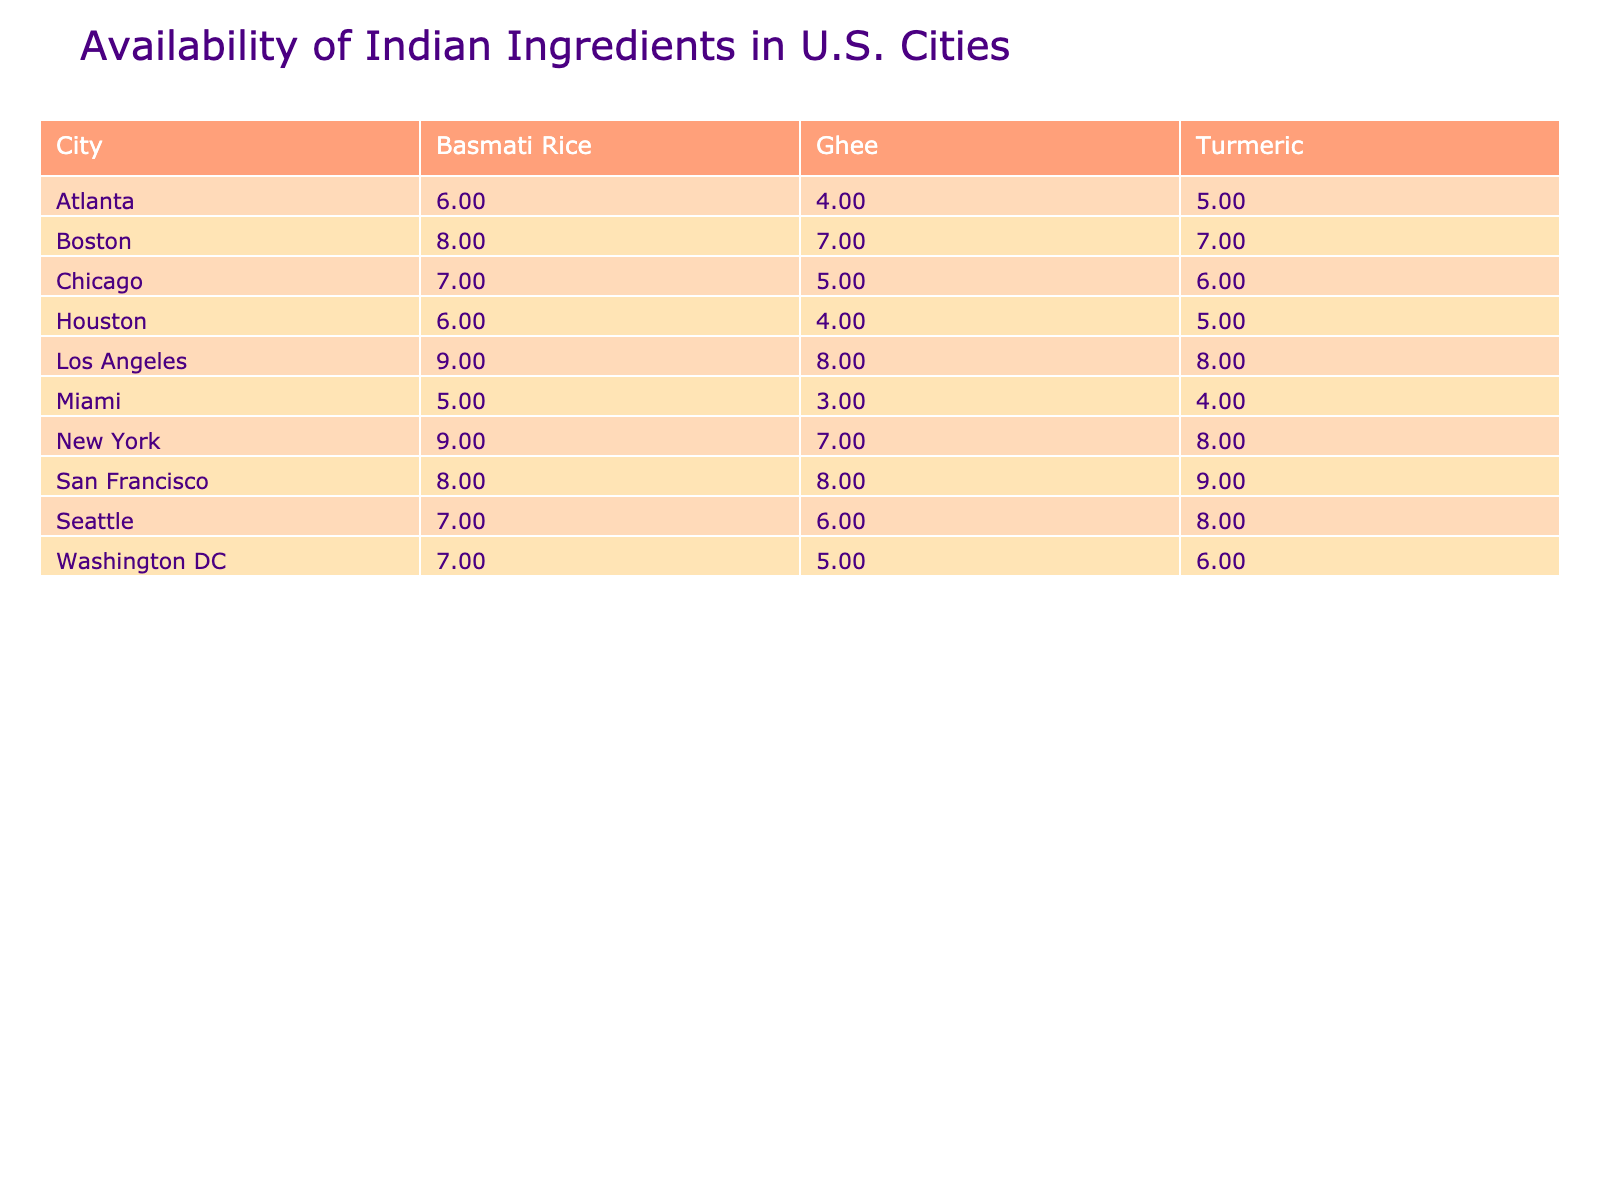What city has the highest availability score for Basmati Rice? By examining the "Availability_Score" for Basmati Rice across all cities, we see that Los Angeles has the highest score of 9.
Answer: Los Angeles Which ingredient has the lowest availability score in Miami? In Miami, the availability scores for the ingredients are: Basmati Rice (5), Turmeric (4), and Ghee (3). Ghee has the lowest score of 3.
Answer: Ghee What is the average availability score for turmeric across all cities? The availability scores for turmeric are: New York (8), Chicago (6), San Francisco (9), Houston (5), Miami (4), Seattle (8), Boston (7), Atlanta (5), Los Angeles (8), and Washington DC (6). Summing these scores gives 66, and there are 10 cities, so the average is 66/10 = 6.6.
Answer: 6.6 Is Ghee more available in Indian Grocery stores than in Specialty Stores? In the table, Ghee has availability scores of 7 in Indian Grocery stores (in New York), 8 (in San Francisco), and 8 (in Los Angeles). In Specialty Stores, it shows 5 (in Washington DC), 4 (in Houston), and 4 (in Atlanta). The scores indicate that Ghee is generally more available in Indian Grocery stores compared to Specialty Stores.
Answer: Yes Which city has the lowest average availability score for Basmati Rice, Turmeric, and Ghee combined? The combined availability scores by city are: New York (9, 8, 7), Chicago (7, 6, 5), San Francisco (8, 9, 8), Houston (6, 5, 4), Miami (5, 4, 3), Seattle (7, 8, 6), Boston (8, 7, 7), Atlanta (6, 5, 4), Los Angeles (9, 8, 8), and Washington DC (7, 6, 5). The sums are: New York (24), Chicago (18), San Francisco (25), Houston (15), Miami (12), Seattle (21), Boston (22), Atlanta (15), Los Angeles (25), and Washington DC (18). Miami has the lowest sum of 12, so it has the lowest average.
Answer: Miami How does the price per pound of Ghee compare between Houston and Los Angeles? In Houston, the price per pound of Ghee is 10.99, while in Los Angeles it is 7.49. Comparing these values shows that Ghee is significantly cheaper in Los Angeles than in Houston.
Answer: Ghee is cheaper in Los Angeles 